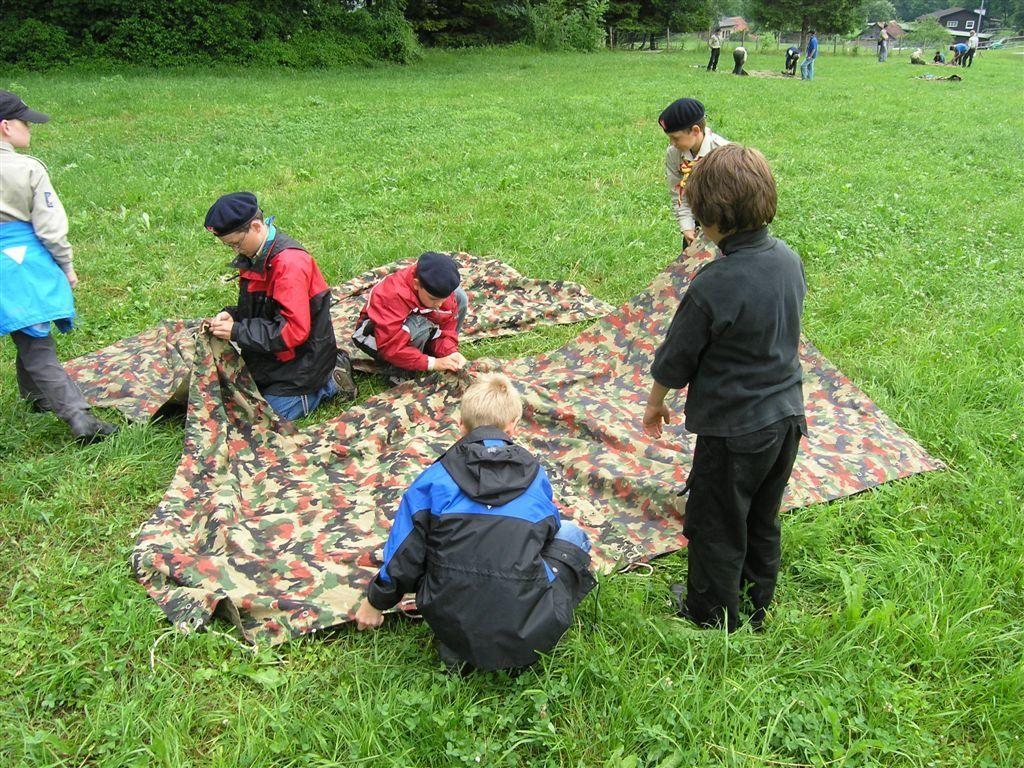What is the main subject of the image? The main subject of the image is groups of people. Can you describe the setting where the people are located? There is a cloth on the grass, which suggests that the people are outdoors. What can be seen in the background of the image? There are trees and houses in the background of the image. What type of corn is being harvested by the people in the image? There is no corn present in the image; it features groups of people in an outdoor setting with a cloth on the grass and trees and houses in the background. 